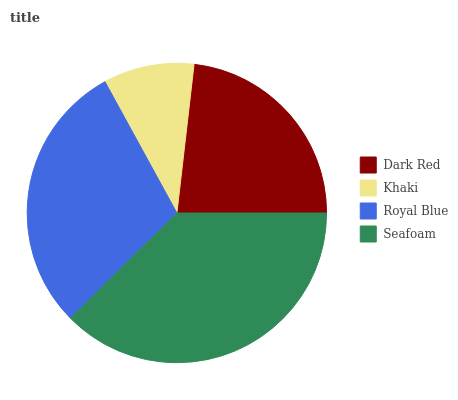Is Khaki the minimum?
Answer yes or no. Yes. Is Seafoam the maximum?
Answer yes or no. Yes. Is Royal Blue the minimum?
Answer yes or no. No. Is Royal Blue the maximum?
Answer yes or no. No. Is Royal Blue greater than Khaki?
Answer yes or no. Yes. Is Khaki less than Royal Blue?
Answer yes or no. Yes. Is Khaki greater than Royal Blue?
Answer yes or no. No. Is Royal Blue less than Khaki?
Answer yes or no. No. Is Royal Blue the high median?
Answer yes or no. Yes. Is Dark Red the low median?
Answer yes or no. Yes. Is Dark Red the high median?
Answer yes or no. No. Is Royal Blue the low median?
Answer yes or no. No. 